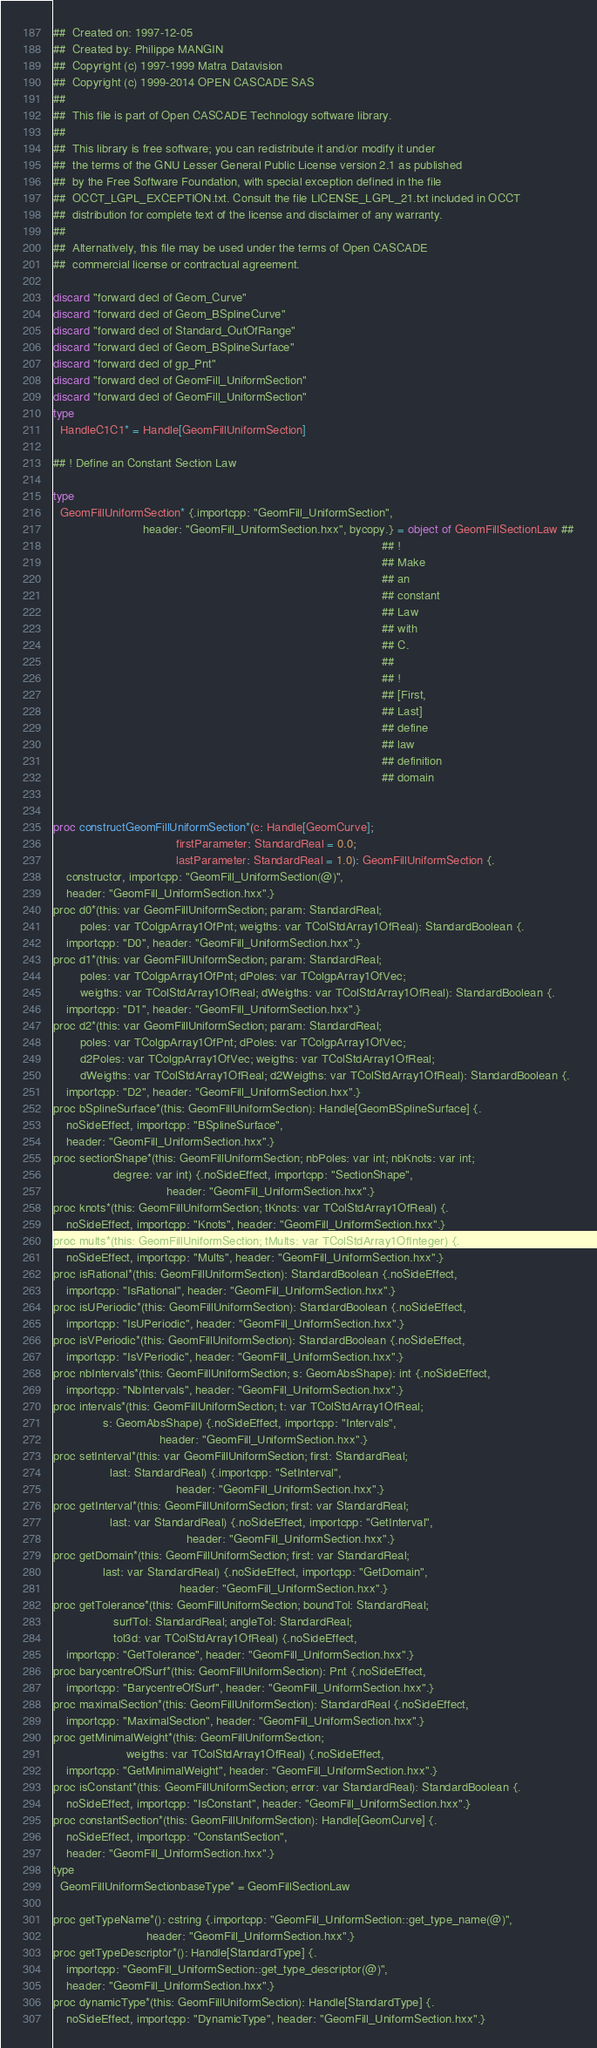<code> <loc_0><loc_0><loc_500><loc_500><_Nim_>##  Created on: 1997-12-05
##  Created by: Philippe MANGIN
##  Copyright (c) 1997-1999 Matra Datavision
##  Copyright (c) 1999-2014 OPEN CASCADE SAS
##
##  This file is part of Open CASCADE Technology software library.
##
##  This library is free software; you can redistribute it and/or modify it under
##  the terms of the GNU Lesser General Public License version 2.1 as published
##  by the Free Software Foundation, with special exception defined in the file
##  OCCT_LGPL_EXCEPTION.txt. Consult the file LICENSE_LGPL_21.txt included in OCCT
##  distribution for complete text of the license and disclaimer of any warranty.
##
##  Alternatively, this file may be used under the terms of Open CASCADE
##  commercial license or contractual agreement.

discard "forward decl of Geom_Curve"
discard "forward decl of Geom_BSplineCurve"
discard "forward decl of Standard_OutOfRange"
discard "forward decl of Geom_BSplineSurface"
discard "forward decl of gp_Pnt"
discard "forward decl of GeomFill_UniformSection"
discard "forward decl of GeomFill_UniformSection"
type
  HandleC1C1* = Handle[GeomFillUniformSection]

## ! Define an Constant Section Law

type
  GeomFillUniformSection* {.importcpp: "GeomFill_UniformSection",
                           header: "GeomFill_UniformSection.hxx", bycopy.} = object of GeomFillSectionLaw ##
                                                                                                   ## !
                                                                                                   ## Make
                                                                                                   ## an
                                                                                                   ## constant
                                                                                                   ## Law
                                                                                                   ## with
                                                                                                   ## C.
                                                                                                   ##
                                                                                                   ## !
                                                                                                   ## [First,
                                                                                                   ## Last]
                                                                                                   ## define
                                                                                                   ## law
                                                                                                   ## definition
                                                                                                   ## domain


proc constructGeomFillUniformSection*(c: Handle[GeomCurve];
                                     firstParameter: StandardReal = 0.0;
                                     lastParameter: StandardReal = 1.0): GeomFillUniformSection {.
    constructor, importcpp: "GeomFill_UniformSection(@)",
    header: "GeomFill_UniformSection.hxx".}
proc d0*(this: var GeomFillUniformSection; param: StandardReal;
        poles: var TColgpArray1OfPnt; weigths: var TColStdArray1OfReal): StandardBoolean {.
    importcpp: "D0", header: "GeomFill_UniformSection.hxx".}
proc d1*(this: var GeomFillUniformSection; param: StandardReal;
        poles: var TColgpArray1OfPnt; dPoles: var TColgpArray1OfVec;
        weigths: var TColStdArray1OfReal; dWeigths: var TColStdArray1OfReal): StandardBoolean {.
    importcpp: "D1", header: "GeomFill_UniformSection.hxx".}
proc d2*(this: var GeomFillUniformSection; param: StandardReal;
        poles: var TColgpArray1OfPnt; dPoles: var TColgpArray1OfVec;
        d2Poles: var TColgpArray1OfVec; weigths: var TColStdArray1OfReal;
        dWeigths: var TColStdArray1OfReal; d2Weigths: var TColStdArray1OfReal): StandardBoolean {.
    importcpp: "D2", header: "GeomFill_UniformSection.hxx".}
proc bSplineSurface*(this: GeomFillUniformSection): Handle[GeomBSplineSurface] {.
    noSideEffect, importcpp: "BSplineSurface",
    header: "GeomFill_UniformSection.hxx".}
proc sectionShape*(this: GeomFillUniformSection; nbPoles: var int; nbKnots: var int;
                  degree: var int) {.noSideEffect, importcpp: "SectionShape",
                                  header: "GeomFill_UniformSection.hxx".}
proc knots*(this: GeomFillUniformSection; tKnots: var TColStdArray1OfReal) {.
    noSideEffect, importcpp: "Knots", header: "GeomFill_UniformSection.hxx".}
proc mults*(this: GeomFillUniformSection; tMults: var TColStdArray1OfInteger) {.
    noSideEffect, importcpp: "Mults", header: "GeomFill_UniformSection.hxx".}
proc isRational*(this: GeomFillUniformSection): StandardBoolean {.noSideEffect,
    importcpp: "IsRational", header: "GeomFill_UniformSection.hxx".}
proc isUPeriodic*(this: GeomFillUniformSection): StandardBoolean {.noSideEffect,
    importcpp: "IsUPeriodic", header: "GeomFill_UniformSection.hxx".}
proc isVPeriodic*(this: GeomFillUniformSection): StandardBoolean {.noSideEffect,
    importcpp: "IsVPeriodic", header: "GeomFill_UniformSection.hxx".}
proc nbIntervals*(this: GeomFillUniformSection; s: GeomAbsShape): int {.noSideEffect,
    importcpp: "NbIntervals", header: "GeomFill_UniformSection.hxx".}
proc intervals*(this: GeomFillUniformSection; t: var TColStdArray1OfReal;
               s: GeomAbsShape) {.noSideEffect, importcpp: "Intervals",
                                header: "GeomFill_UniformSection.hxx".}
proc setInterval*(this: var GeomFillUniformSection; first: StandardReal;
                 last: StandardReal) {.importcpp: "SetInterval",
                                     header: "GeomFill_UniformSection.hxx".}
proc getInterval*(this: GeomFillUniformSection; first: var StandardReal;
                 last: var StandardReal) {.noSideEffect, importcpp: "GetInterval",
                                        header: "GeomFill_UniformSection.hxx".}
proc getDomain*(this: GeomFillUniformSection; first: var StandardReal;
               last: var StandardReal) {.noSideEffect, importcpp: "GetDomain",
                                      header: "GeomFill_UniformSection.hxx".}
proc getTolerance*(this: GeomFillUniformSection; boundTol: StandardReal;
                  surfTol: StandardReal; angleTol: StandardReal;
                  tol3d: var TColStdArray1OfReal) {.noSideEffect,
    importcpp: "GetTolerance", header: "GeomFill_UniformSection.hxx".}
proc barycentreOfSurf*(this: GeomFillUniformSection): Pnt {.noSideEffect,
    importcpp: "BarycentreOfSurf", header: "GeomFill_UniformSection.hxx".}
proc maximalSection*(this: GeomFillUniformSection): StandardReal {.noSideEffect,
    importcpp: "MaximalSection", header: "GeomFill_UniformSection.hxx".}
proc getMinimalWeight*(this: GeomFillUniformSection;
                      weigths: var TColStdArray1OfReal) {.noSideEffect,
    importcpp: "GetMinimalWeight", header: "GeomFill_UniformSection.hxx".}
proc isConstant*(this: GeomFillUniformSection; error: var StandardReal): StandardBoolean {.
    noSideEffect, importcpp: "IsConstant", header: "GeomFill_UniformSection.hxx".}
proc constantSection*(this: GeomFillUniformSection): Handle[GeomCurve] {.
    noSideEffect, importcpp: "ConstantSection",
    header: "GeomFill_UniformSection.hxx".}
type
  GeomFillUniformSectionbaseType* = GeomFillSectionLaw

proc getTypeName*(): cstring {.importcpp: "GeomFill_UniformSection::get_type_name(@)",
                            header: "GeomFill_UniformSection.hxx".}
proc getTypeDescriptor*(): Handle[StandardType] {.
    importcpp: "GeomFill_UniformSection::get_type_descriptor(@)",
    header: "GeomFill_UniformSection.hxx".}
proc dynamicType*(this: GeomFillUniformSection): Handle[StandardType] {.
    noSideEffect, importcpp: "DynamicType", header: "GeomFill_UniformSection.hxx".}</code> 